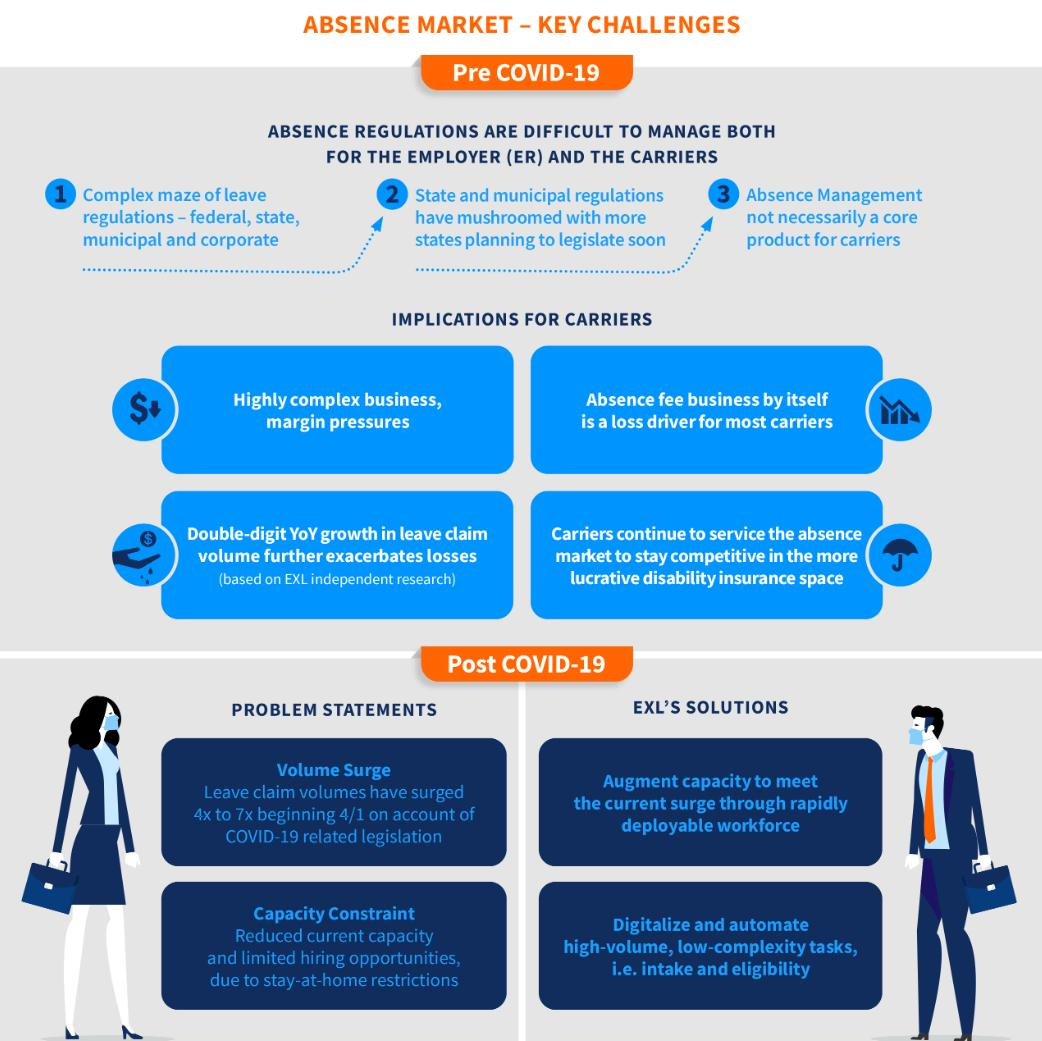Identify some key points in this picture. High-volume, low-complexity tasks can be digitized and automated. The current capacity constraint is due to stay-at-home restrictions. To address the capacity constraint problem due to stay-at-home restrictions, it is recommended to digitize and automate high-volume, low-complexity tasks such as intake and eligibility determination in order to increase efficiency and reduce reliance on human staff. The leave claim volumes have increased significantly from the 1st of April, with a growth rate of 4x to 7x compared to the previous period. EXL has developed a solution to address the challenges of volume surge by augmenting our capacity through the rapid deployment of a highly skilled and trained workforce. 